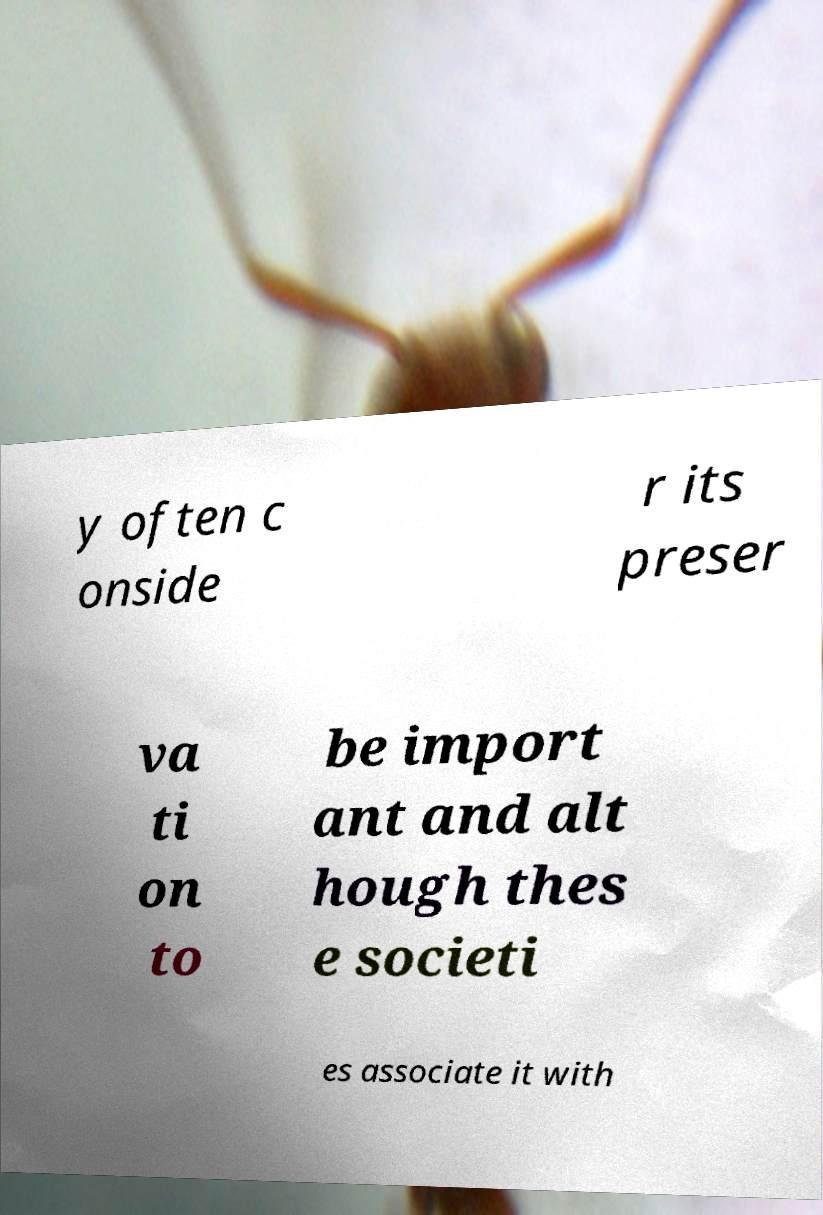I need the written content from this picture converted into text. Can you do that? y often c onside r its preser va ti on to be import ant and alt hough thes e societi es associate it with 